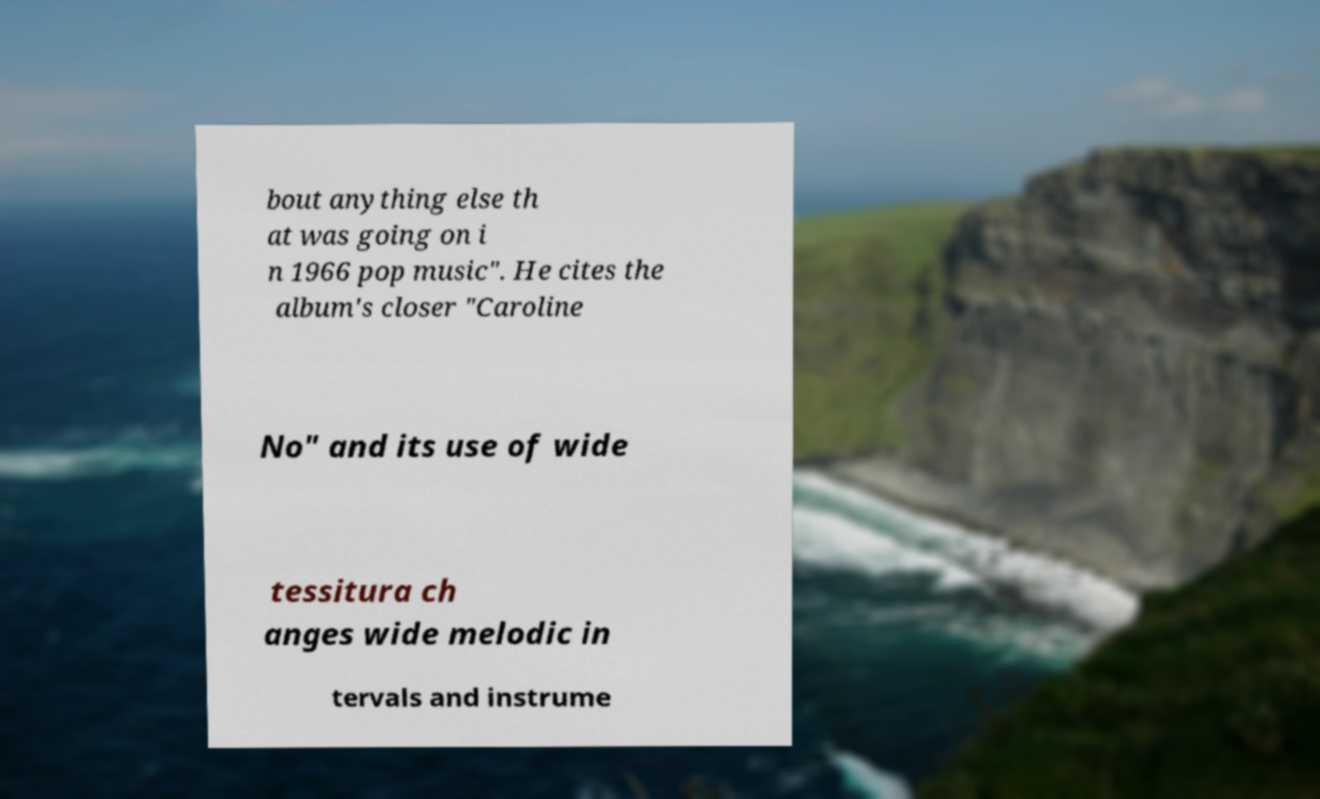Please identify and transcribe the text found in this image. bout anything else th at was going on i n 1966 pop music". He cites the album's closer "Caroline No" and its use of wide tessitura ch anges wide melodic in tervals and instrume 